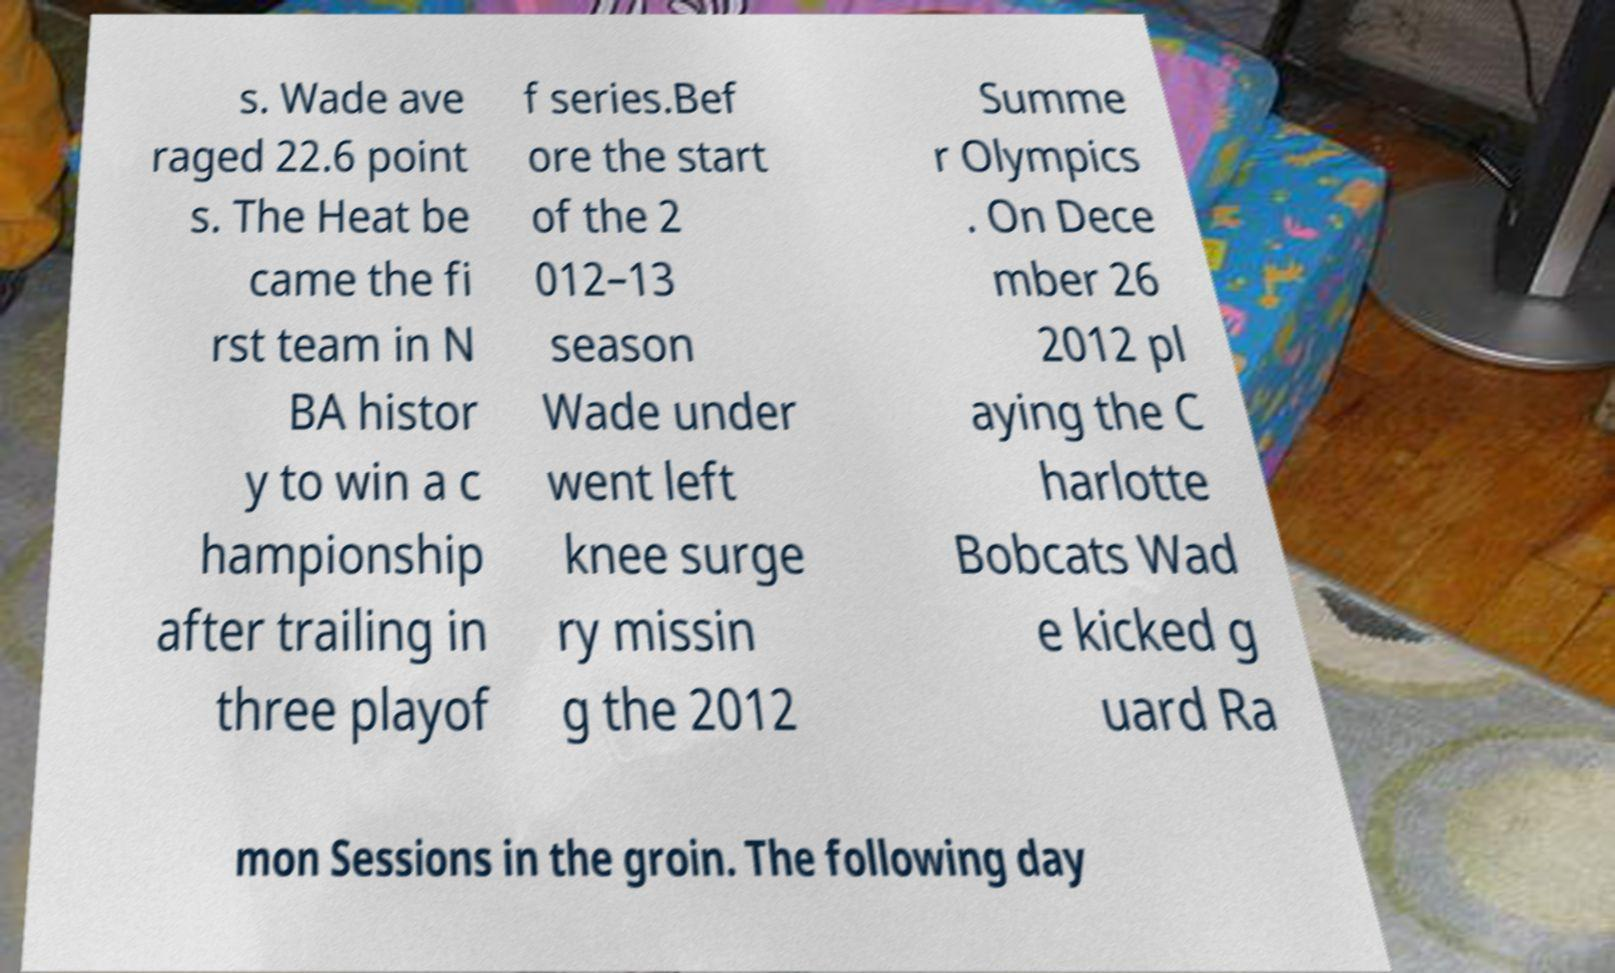Please identify and transcribe the text found in this image. s. Wade ave raged 22.6 point s. The Heat be came the fi rst team in N BA histor y to win a c hampionship after trailing in three playof f series.Bef ore the start of the 2 012–13 season Wade under went left knee surge ry missin g the 2012 Summe r Olympics . On Dece mber 26 2012 pl aying the C harlotte Bobcats Wad e kicked g uard Ra mon Sessions in the groin. The following day 